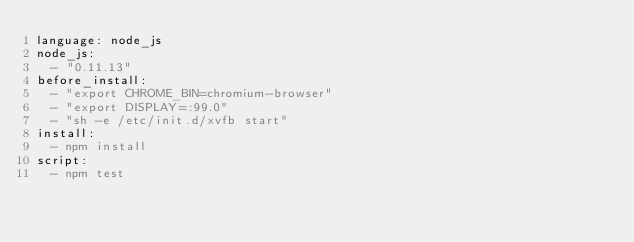<code> <loc_0><loc_0><loc_500><loc_500><_YAML_>language: node_js
node_js:
  - "0.11.13"
before_install:
  - "export CHROME_BIN=chromium-browser"
  - "export DISPLAY=:99.0"
  - "sh -e /etc/init.d/xvfb start"
install:
  - npm install
script:
  - npm test

</code> 